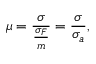Convert formula to latex. <formula><loc_0><loc_0><loc_500><loc_500>\mu = \frac { \sigma } { \frac { \sigma _ { F } } { m } } = \frac { \sigma } { \sigma _ { a } } ,</formula> 